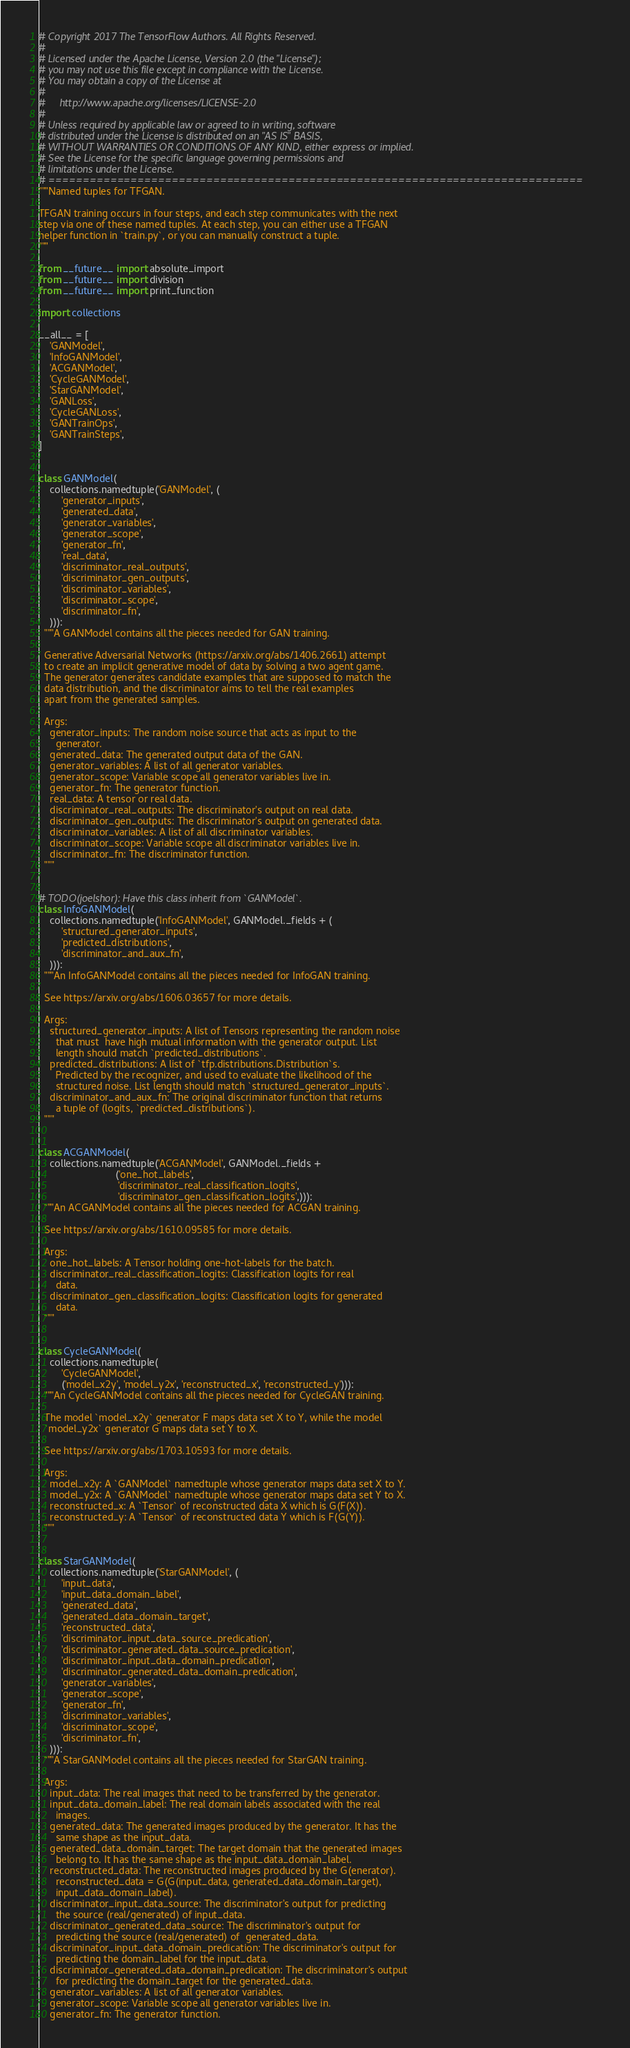Convert code to text. <code><loc_0><loc_0><loc_500><loc_500><_Python_># Copyright 2017 The TensorFlow Authors. All Rights Reserved.
#
# Licensed under the Apache License, Version 2.0 (the "License");
# you may not use this file except in compliance with the License.
# You may obtain a copy of the License at
#
#     http://www.apache.org/licenses/LICENSE-2.0
#
# Unless required by applicable law or agreed to in writing, software
# distributed under the License is distributed on an "AS IS" BASIS,
# WITHOUT WARRANTIES OR CONDITIONS OF ANY KIND, either express or implied.
# See the License for the specific language governing permissions and
# limitations under the License.
# ==============================================================================
"""Named tuples for TFGAN.

TFGAN training occurs in four steps, and each step communicates with the next
step via one of these named tuples. At each step, you can either use a TFGAN
helper function in `train.py`, or you can manually construct a tuple.
"""

from __future__ import absolute_import
from __future__ import division
from __future__ import print_function

import collections

__all__ = [
    'GANModel',
    'InfoGANModel',
    'ACGANModel',
    'CycleGANModel',
    'StarGANModel',
    'GANLoss',
    'CycleGANLoss',
    'GANTrainOps',
    'GANTrainSteps',
]


class GANModel(
    collections.namedtuple('GANModel', (
        'generator_inputs',
        'generated_data',
        'generator_variables',
        'generator_scope',
        'generator_fn',
        'real_data',
        'discriminator_real_outputs',
        'discriminator_gen_outputs',
        'discriminator_variables',
        'discriminator_scope',
        'discriminator_fn',
    ))):
  """A GANModel contains all the pieces needed for GAN training.

  Generative Adversarial Networks (https://arxiv.org/abs/1406.2661) attempt
  to create an implicit generative model of data by solving a two agent game.
  The generator generates candidate examples that are supposed to match the
  data distribution, and the discriminator aims to tell the real examples
  apart from the generated samples.

  Args:
    generator_inputs: The random noise source that acts as input to the
      generator.
    generated_data: The generated output data of the GAN.
    generator_variables: A list of all generator variables.
    generator_scope: Variable scope all generator variables live in.
    generator_fn: The generator function.
    real_data: A tensor or real data.
    discriminator_real_outputs: The discriminator's output on real data.
    discriminator_gen_outputs: The discriminator's output on generated data.
    discriminator_variables: A list of all discriminator variables.
    discriminator_scope: Variable scope all discriminator variables live in.
    discriminator_fn: The discriminator function.
  """


# TODO(joelshor): Have this class inherit from `GANModel`.
class InfoGANModel(
    collections.namedtuple('InfoGANModel', GANModel._fields + (
        'structured_generator_inputs',
        'predicted_distributions',
        'discriminator_and_aux_fn',
    ))):
  """An InfoGANModel contains all the pieces needed for InfoGAN training.

  See https://arxiv.org/abs/1606.03657 for more details.

  Args:
    structured_generator_inputs: A list of Tensors representing the random noise
      that must  have high mutual information with the generator output. List
      length should match `predicted_distributions`.
    predicted_distributions: A list of `tfp.distributions.Distribution`s.
      Predicted by the recognizer, and used to evaluate the likelihood of the
      structured noise. List length should match `structured_generator_inputs`.
    discriminator_and_aux_fn: The original discriminator function that returns
      a tuple of (logits, `predicted_distributions`).
  """


class ACGANModel(
    collections.namedtuple('ACGANModel', GANModel._fields +
                           ('one_hot_labels',
                            'discriminator_real_classification_logits',
                            'discriminator_gen_classification_logits',))):
  """An ACGANModel contains all the pieces needed for ACGAN training.

  See https://arxiv.org/abs/1610.09585 for more details.

  Args:
    one_hot_labels: A Tensor holding one-hot-labels for the batch.
    discriminator_real_classification_logits: Classification logits for real
      data.
    discriminator_gen_classification_logits: Classification logits for generated
      data.
  """


class CycleGANModel(
    collections.namedtuple(
        'CycleGANModel',
        ('model_x2y', 'model_y2x', 'reconstructed_x', 'reconstructed_y'))):
  """An CycleGANModel contains all the pieces needed for CycleGAN training.

  The model `model_x2y` generator F maps data set X to Y, while the model
  `model_y2x` generator G maps data set Y to X.

  See https://arxiv.org/abs/1703.10593 for more details.

  Args:
    model_x2y: A `GANModel` namedtuple whose generator maps data set X to Y.
    model_y2x: A `GANModel` namedtuple whose generator maps data set Y to X.
    reconstructed_x: A `Tensor` of reconstructed data X which is G(F(X)).
    reconstructed_y: A `Tensor` of reconstructed data Y which is F(G(Y)).
  """


class StarGANModel(
    collections.namedtuple('StarGANModel', (
        'input_data',
        'input_data_domain_label',
        'generated_data',
        'generated_data_domain_target',
        'reconstructed_data',
        'discriminator_input_data_source_predication',
        'discriminator_generated_data_source_predication',
        'discriminator_input_data_domain_predication',
        'discriminator_generated_data_domain_predication',
        'generator_variables',
        'generator_scope',
        'generator_fn',
        'discriminator_variables',
        'discriminator_scope',
        'discriminator_fn',
    ))):
  """A StarGANModel contains all the pieces needed for StarGAN training.

  Args:
    input_data: The real images that need to be transferred by the generator.
    input_data_domain_label: The real domain labels associated with the real
      images.
    generated_data: The generated images produced by the generator. It has the
      same shape as the input_data.
    generated_data_domain_target: The target domain that the generated images
      belong to. It has the same shape as the input_data_domain_label.
    reconstructed_data: The reconstructed images produced by the G(enerator).
      reconstructed_data = G(G(input_data, generated_data_domain_target),
      input_data_domain_label).
    discriminator_input_data_source: The discriminator's output for predicting
      the source (real/generated) of input_data.
    discriminator_generated_data_source: The discriminator's output for
      predicting the source (real/generated) of  generated_data.
    discriminator_input_data_domain_predication: The discriminator's output for
      predicting the domain_label for the input_data.
    discriminator_generated_data_domain_predication: The discriminatorr's output
      for predicting the domain_target for the generated_data.
    generator_variables: A list of all generator variables.
    generator_scope: Variable scope all generator variables live in.
    generator_fn: The generator function.</code> 